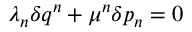<formula> <loc_0><loc_0><loc_500><loc_500>\lambda _ { n } \delta q ^ { n } + \mu ^ { n } \delta p _ { n } = 0</formula> 